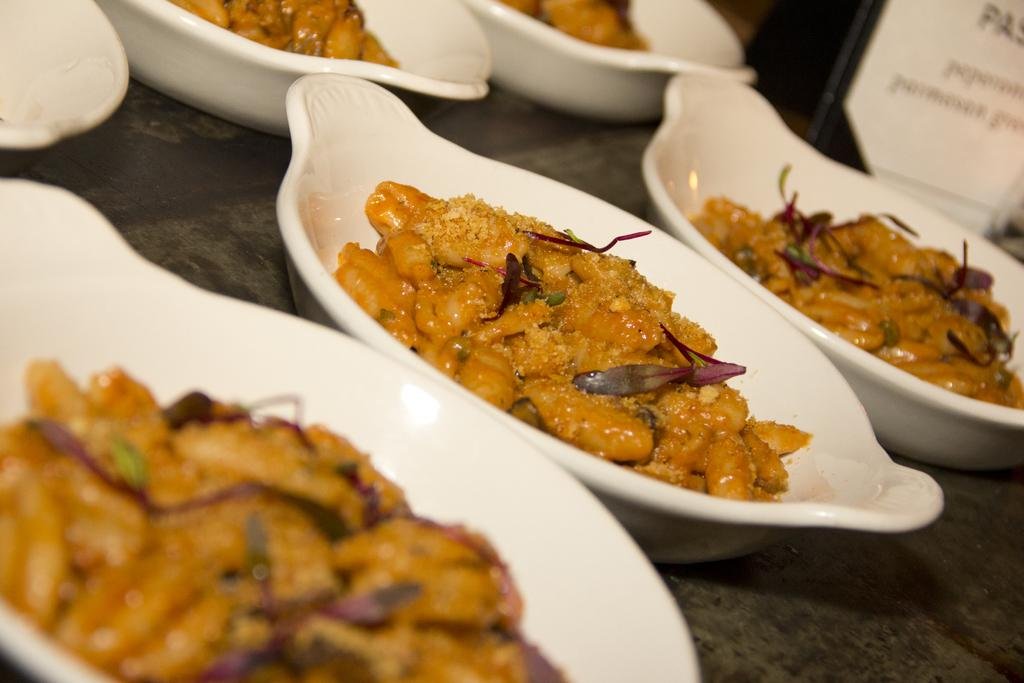What is in the bowls that are visible in the image? There are bowls with food in the image. Can you describe the object that is on the surface in the image? Unfortunately, the provided facts do not give enough information to describe the object on the surface in the image. What type of rings are being worn by the people in the image? There are no people present in the image, so it is not possible to determine if anyone is wearing rings. 